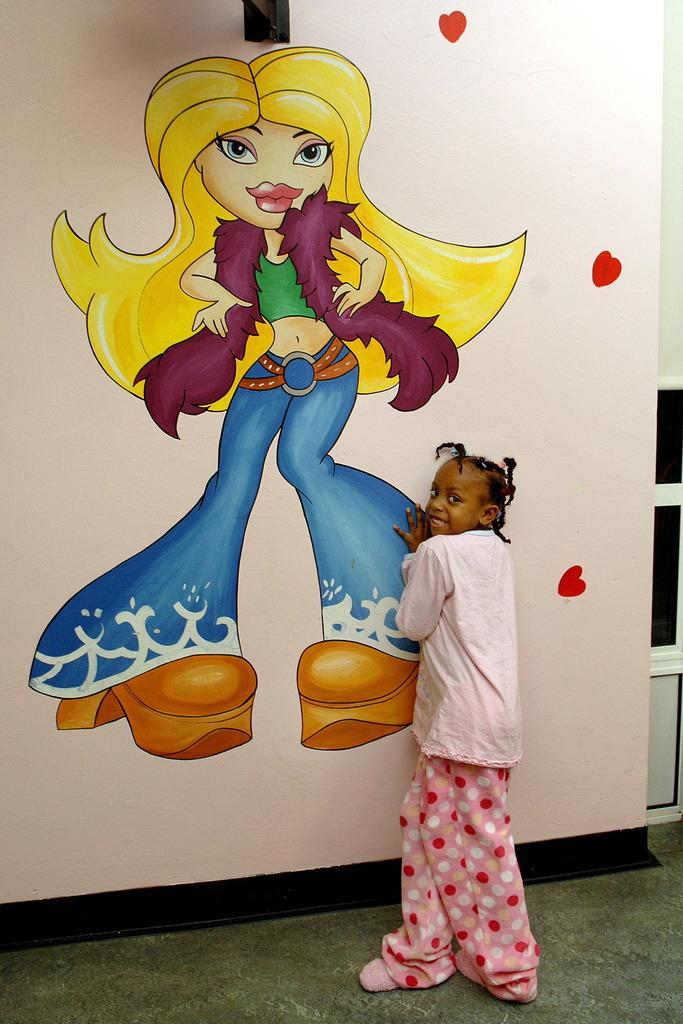What is the main subject of the image? There is a girl standing in the image. Can you describe the girl's appearance? The girl is wearing clothes. What type of surface is visible in the image? The image shows a floor. What other elements can be seen in the background? There is a wall in the image. Is there any artwork on the wall? Yes, there is a painting of a girl on the wall. Where is the quince located in the image? There is no quince present in the image. What type of throne is the girl sitting on in the image? The girl is standing, not sitting on a throne, in the image. 